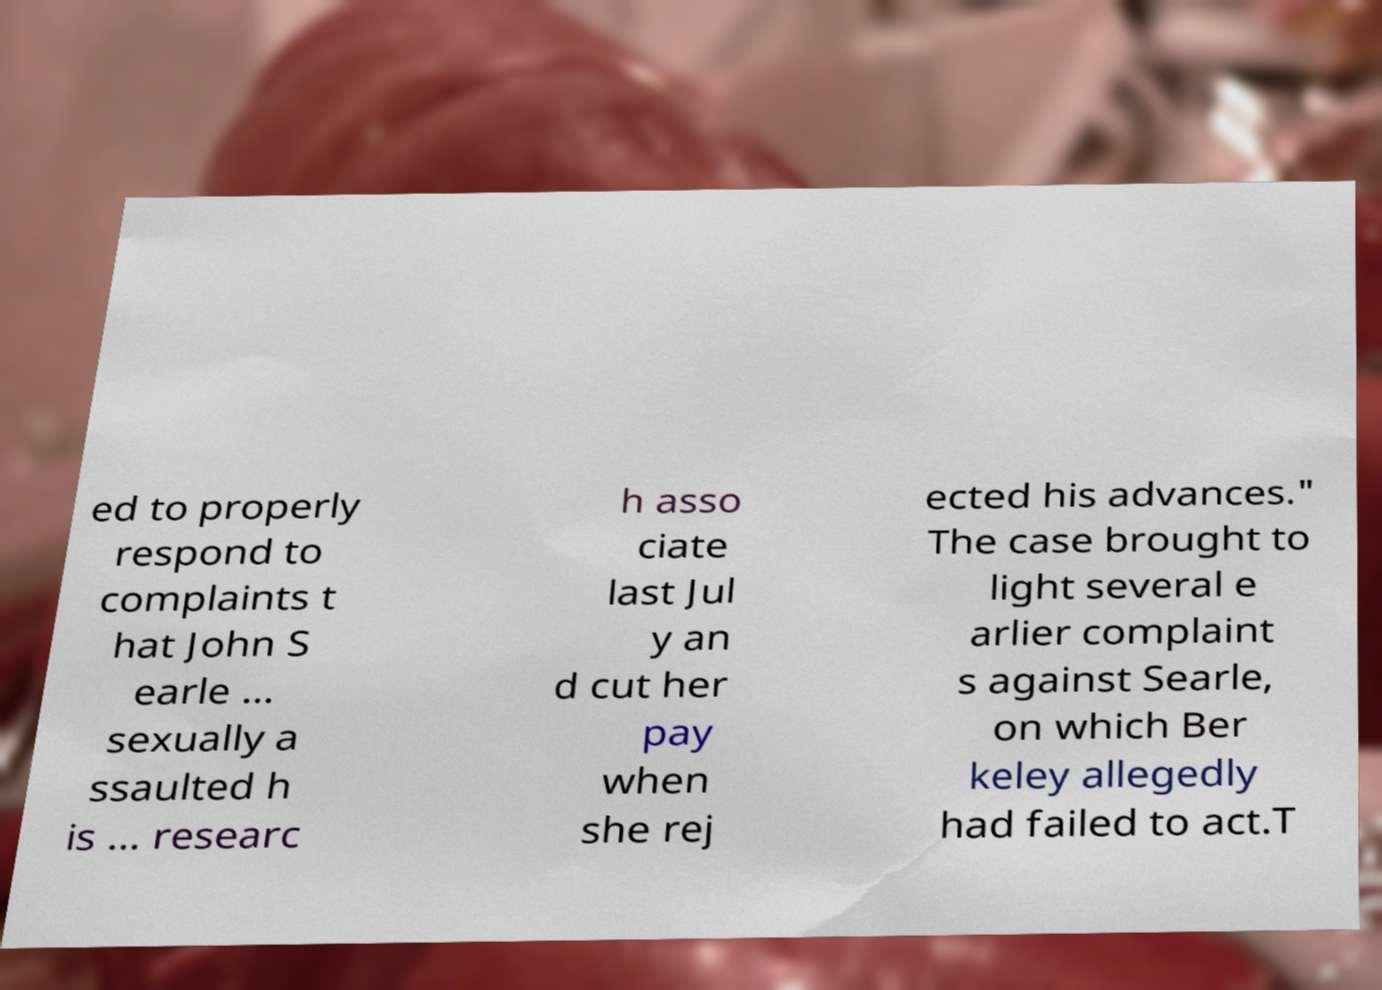I need the written content from this picture converted into text. Can you do that? ed to properly respond to complaints t hat John S earle ... sexually a ssaulted h is ... researc h asso ciate last Jul y an d cut her pay when she rej ected his advances." The case brought to light several e arlier complaint s against Searle, on which Ber keley allegedly had failed to act.T 